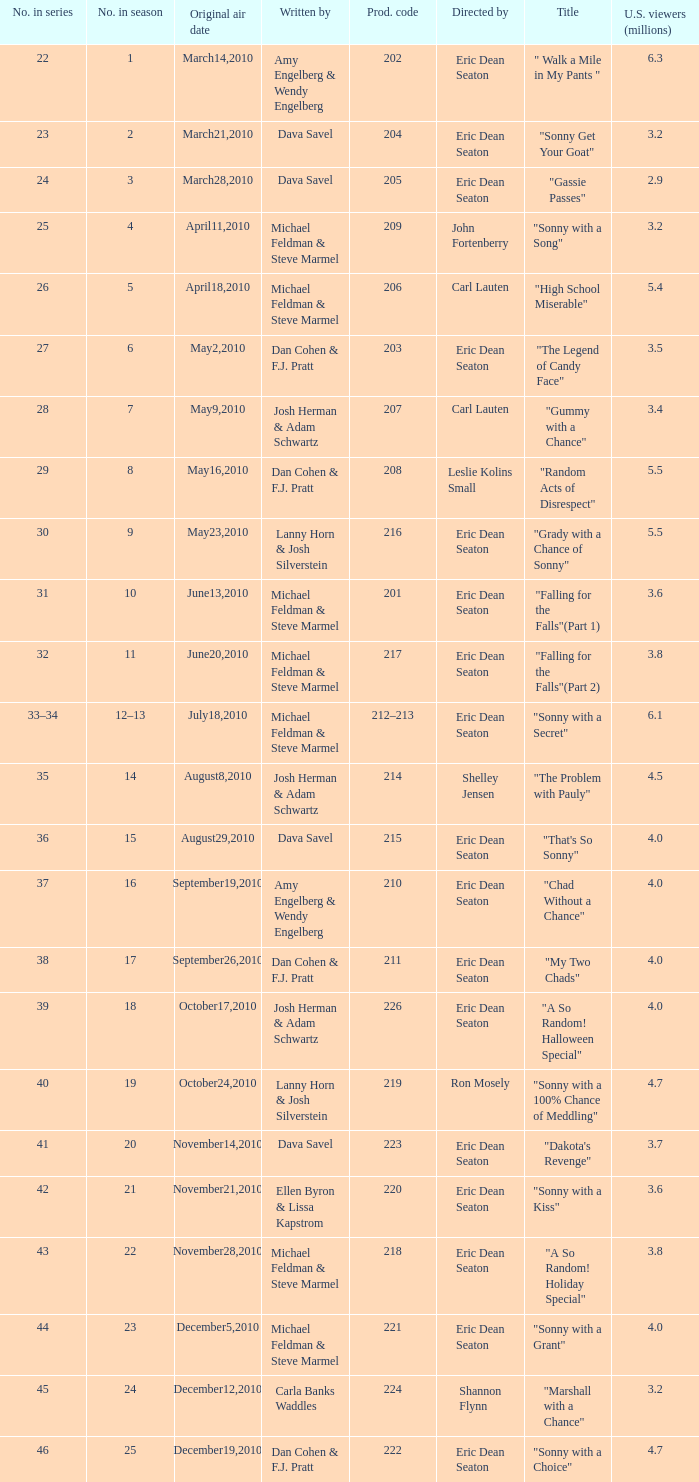Who directed the episode that 6.3 million u.s. viewers saw? Eric Dean Seaton. 